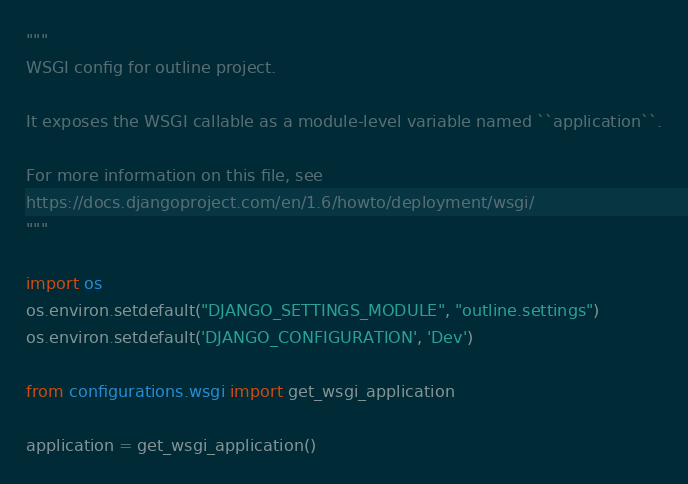<code> <loc_0><loc_0><loc_500><loc_500><_Python_>"""
WSGI config for outline project.

It exposes the WSGI callable as a module-level variable named ``application``.

For more information on this file, see
https://docs.djangoproject.com/en/1.6/howto/deployment/wsgi/
"""

import os
os.environ.setdefault("DJANGO_SETTINGS_MODULE", "outline.settings")
os.environ.setdefault('DJANGO_CONFIGURATION', 'Dev')

from configurations.wsgi import get_wsgi_application

application = get_wsgi_application()
</code> 